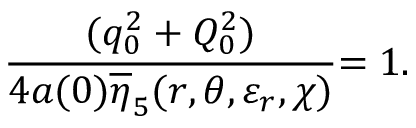<formula> <loc_0><loc_0><loc_500><loc_500>\frac { ( q _ { 0 } ^ { 2 } + Q _ { 0 } ^ { 2 } ) } { 4 a ( 0 ) \overline { \eta } _ { 5 } ( r , \theta , \varepsilon _ { r } , \chi ) } { = 1 . }</formula> 